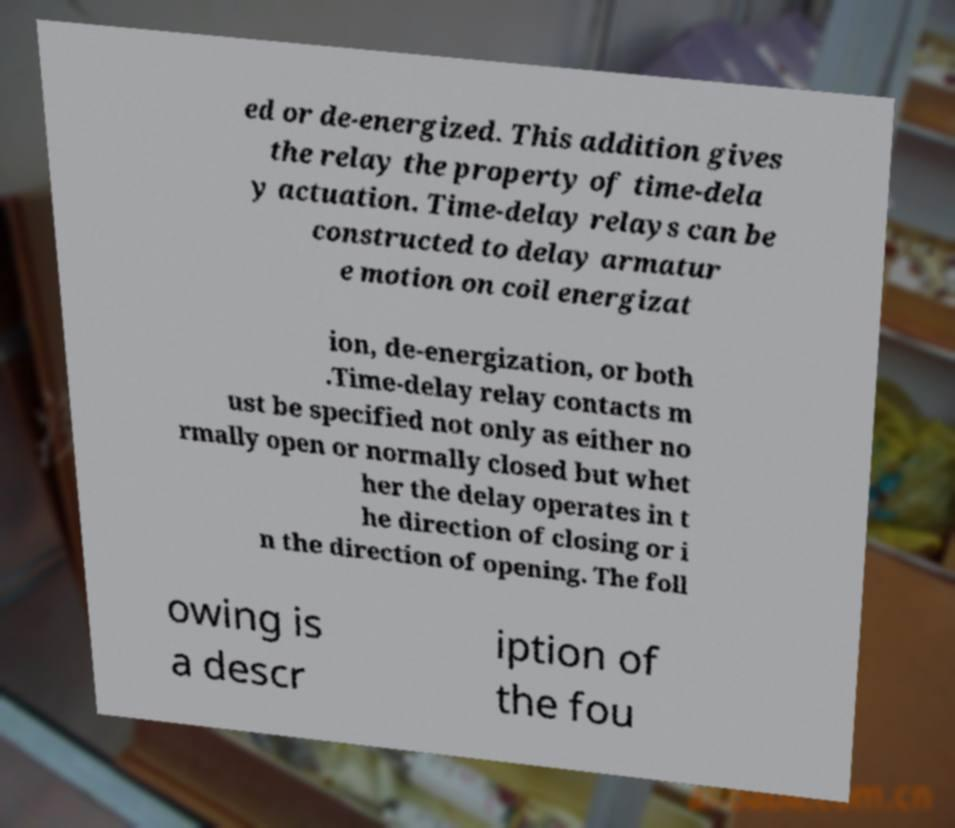Could you assist in decoding the text presented in this image and type it out clearly? ed or de-energized. This addition gives the relay the property of time-dela y actuation. Time-delay relays can be constructed to delay armatur e motion on coil energizat ion, de-energization, or both .Time-delay relay contacts m ust be specified not only as either no rmally open or normally closed but whet her the delay operates in t he direction of closing or i n the direction of opening. The foll owing is a descr iption of the fou 